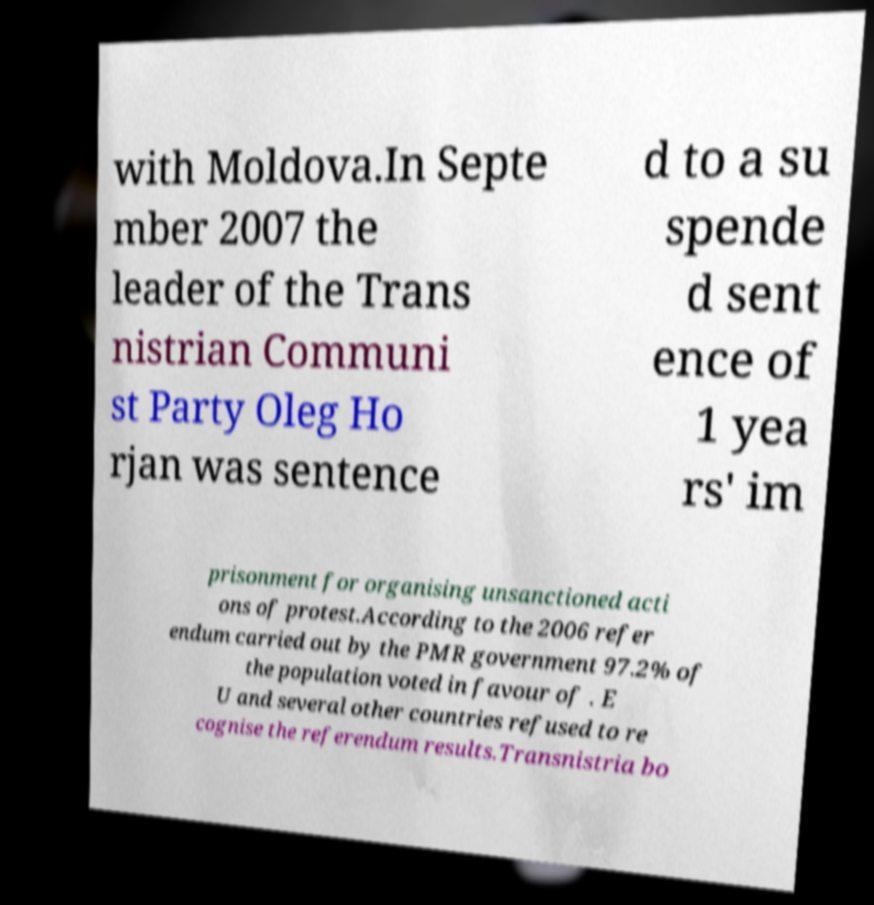Please identify and transcribe the text found in this image. with Moldova.In Septe mber 2007 the leader of the Trans nistrian Communi st Party Oleg Ho rjan was sentence d to a su spende d sent ence of 1 yea rs' im prisonment for organising unsanctioned acti ons of protest.According to the 2006 refer endum carried out by the PMR government 97.2% of the population voted in favour of . E U and several other countries refused to re cognise the referendum results.Transnistria bo 